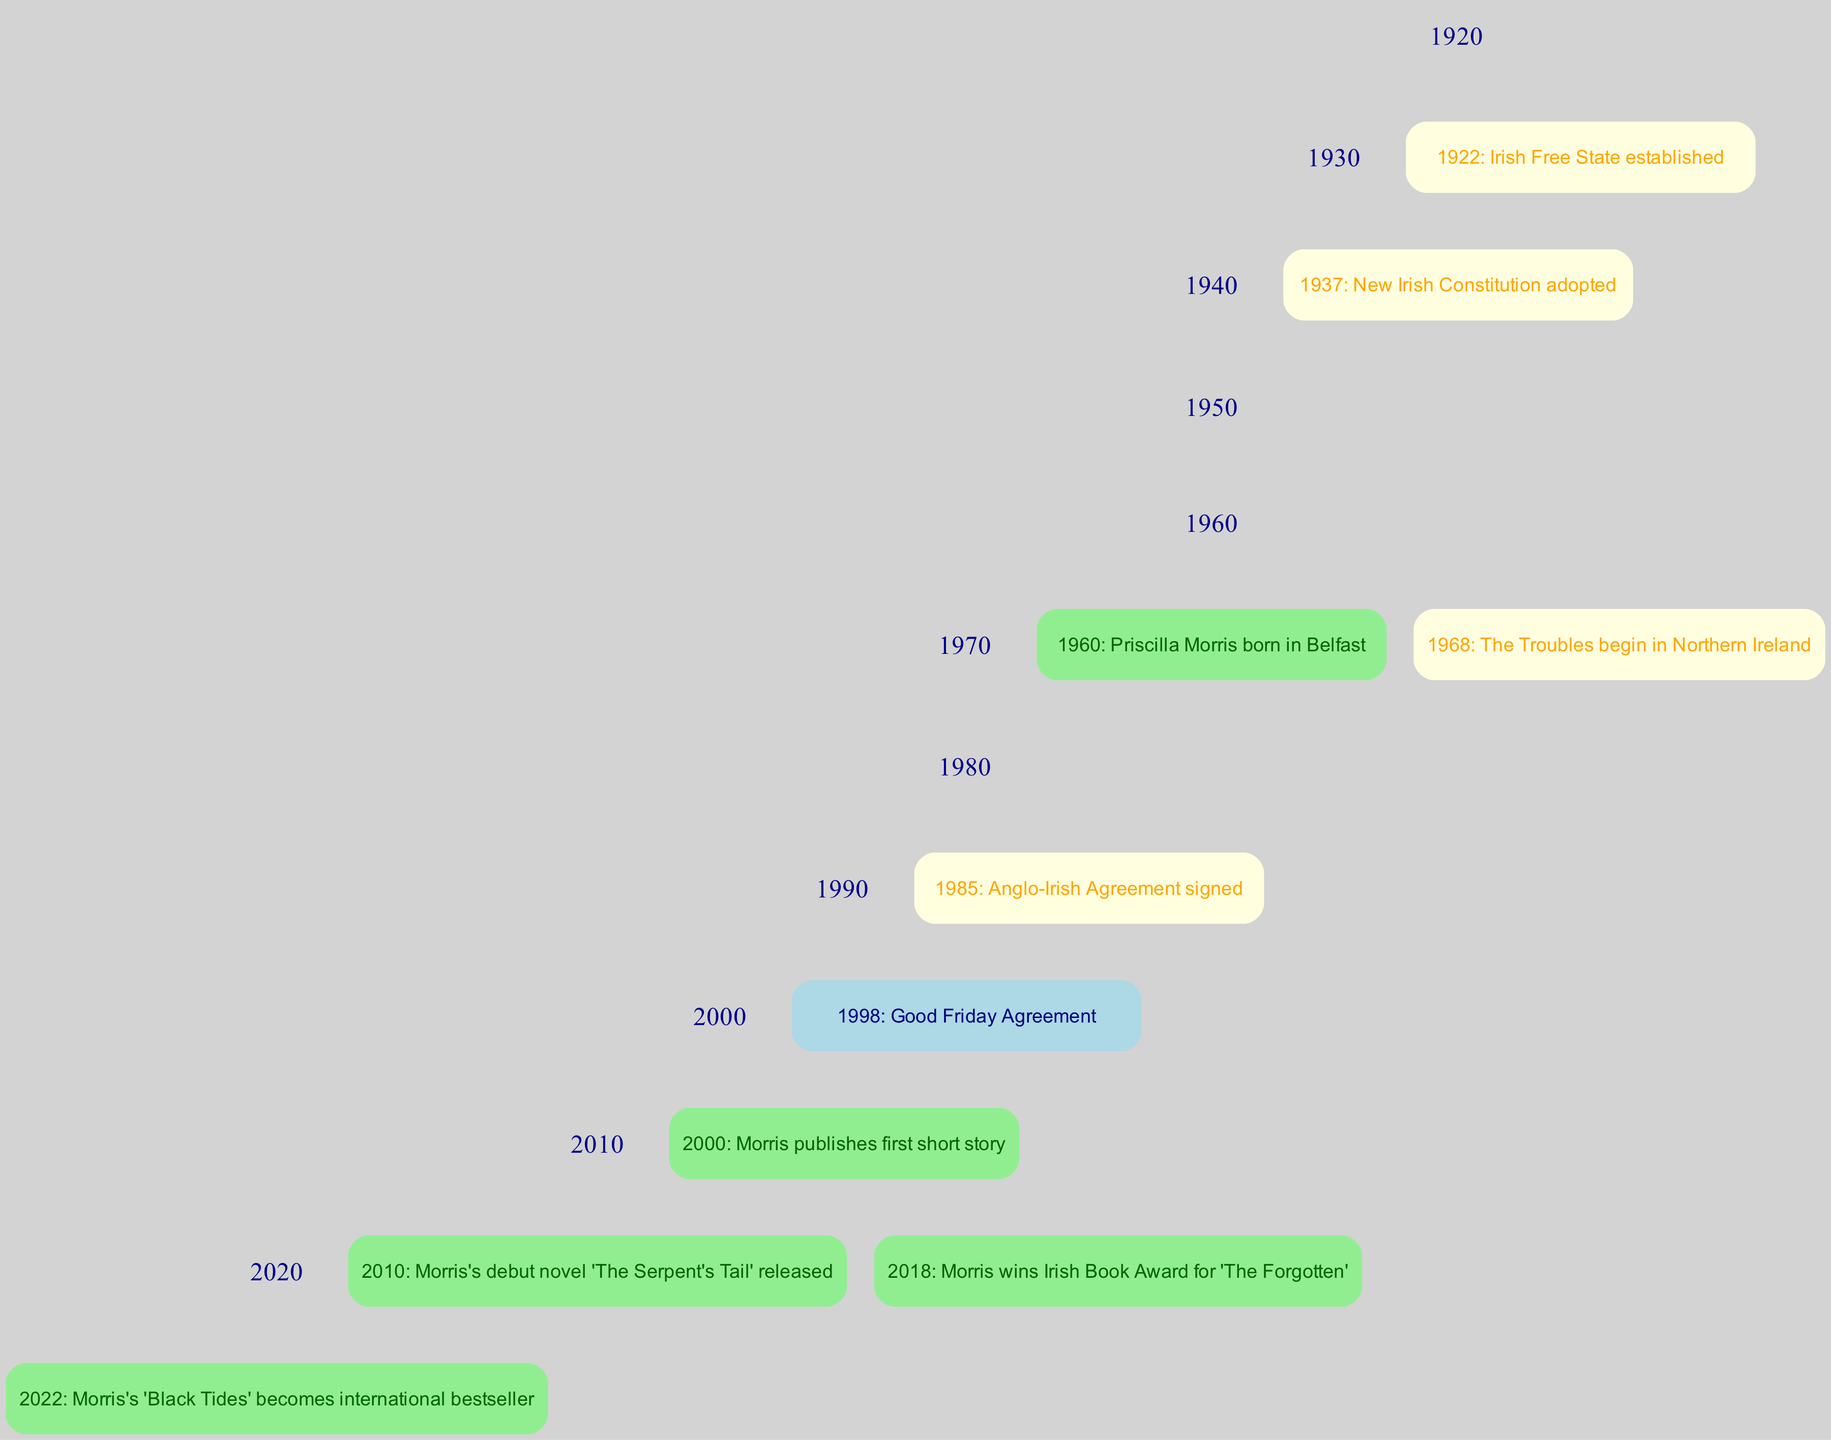What significant event occurred in 1998? The diagram indicates that in 1998, the event "Good Friday Agreement" took place. This is represented as a node connected to the timeline for that specific year.
Answer: Good Friday Agreement How many significant events are mentioned in the timeline? By counting each event listed in the timeline, we see that there are a total of ten events spanning from 1922 to 2022. Each event is represented as a node on the timeline.
Answer: 10 What color represents events related to Morris? Events related to Morris are denoted in light green. This is determined by evaluating the color coding used for the specific node events within the timeline.
Answer: light green In what decade was Morris's debut novel released? By locating the event "Morris's debut novel 'The Serpent's Tail' released" in the timeline, we find it corresponds to the year 2010, which falls in the decade of the 2010s.
Answer: 2010s What event happened in the same year as Morris's birth? The diagram shows that Priscilla Morris was born in Belfast in 1960. Looking at the events in that year, we see no other events listed; hence, this is the sole event for that year.
Answer: Irish Free State established Which event is directly associated with the beginning of The Troubles? The timeline indicates that the event "The Troubles begin in Northern Ireland" occurred in 1968, marking a significant moment in Irish history and influencing the context of Morris's writing.
Answer: The Troubles begin in Northern Ireland What was the first publication by Morris? According to the timeline, her first publication was a short story in the year 2000, which is clearly stated as "Morris publishes first short story."
Answer: Morris publishes first short story Which decade saw the signing of the Anglo-Irish Agreement? The event "Anglo-Irish Agreement signed" is noted in 1985, which indicates it occurred in the decade of the 1980s according to the timeline structure.
Answer: 1980s In what year did Morris win the Irish Book Award? The diagram specifies that in 2018, Morris won the Irish Book Award for her work titled "The Forgotten." This year marks a significant achievement in her career.
Answer: 2018 